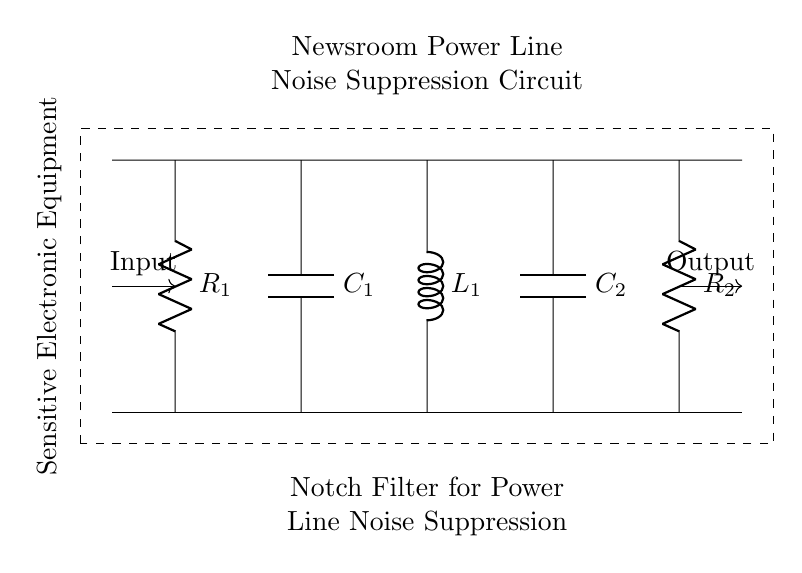What is the purpose of this circuit? The circuit's purpose is to suppress power line noise, specifically designed for sensitive electronic equipment in a newsroom environment.
Answer: Power line noise suppression How many resistors are in the circuit? There are two resistors shown in the circuit diagram, labeled as R1 and R2. Each plays a role in the filter operation.
Answer: Two What components make up the notch filter? The notch filter comprises two resistors (R1, R2), two capacitors (C1, C2), and one inductor (L1). These combine to create a specific frequency response that attenuates unwanted noise frequencies.
Answer: R1, R2, C1, C2, L1 What is the position of the input in the circuit? The input is positioned at the left side of the circuit, where it connects to R1. This point serves as the entry for the signal to be filtered.
Answer: Left side What role does the inductor play in this circuit? The inductor (L1) helps to create a notch in the frequency response by storing energy in a magnetic field, particularly at the noise frequency, thus allowing the circuit to filter out those specific unwanted frequencies.
Answer: Frequency filtering What is the significance of the dashed rectangle in the diagram? The dashed rectangle indicates the boundaries of the entire circuit, visually separating it to signify that it is a complete unit designed for a specific function.
Answer: Circuit boundaries What output can be expected from this circuit? The output, located at the right side of the circuit, will be a cleaner signal devoid of the previously present power line noise, suitable for sensitive electronic devices.
Answer: Cleaner signal 